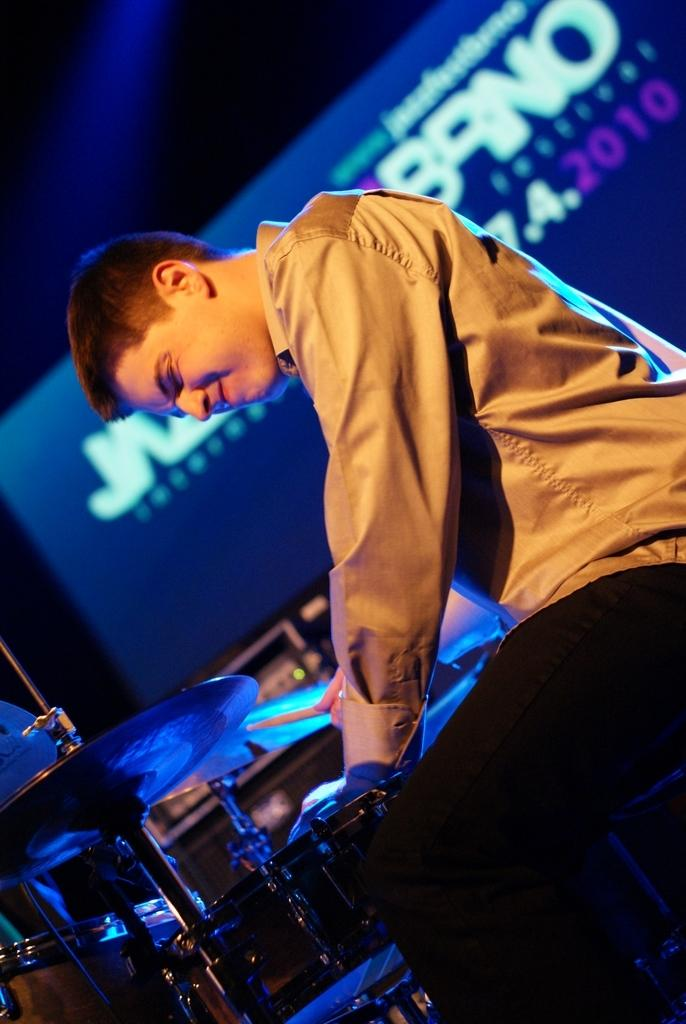Who is the main subject in the image? There is a man in the image. What is the man wearing? The man is wearing a shirt. What is the man doing in the image? The man is playing the snare drum musical instrument. What can be seen in the background of the image? There is a screen in the background of the image. What is written or displayed on the screen? There is text on the screen. Is the man teaching a swimming lesson in the image? No, the man is not teaching a swimming lesson in the image; he is playing the snare drum. 